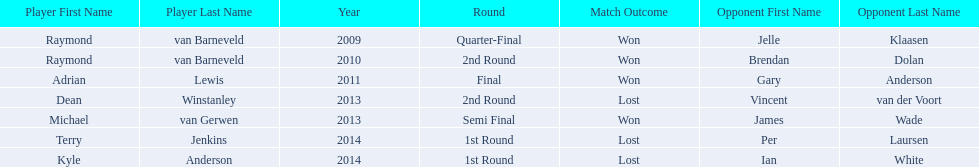Who were all the players? Raymond van Barneveld, Raymond van Barneveld, Adrian Lewis, Dean Winstanley, Michael van Gerwen, Terry Jenkins, Kyle Anderson. Which of these played in 2014? Terry Jenkins, Kyle Anderson. Who were their opponents? Per Laursen, Ian White. Which of these beat terry jenkins? Per Laursen. 